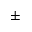Convert formula to latex. <formula><loc_0><loc_0><loc_500><loc_500>\pm</formula> 